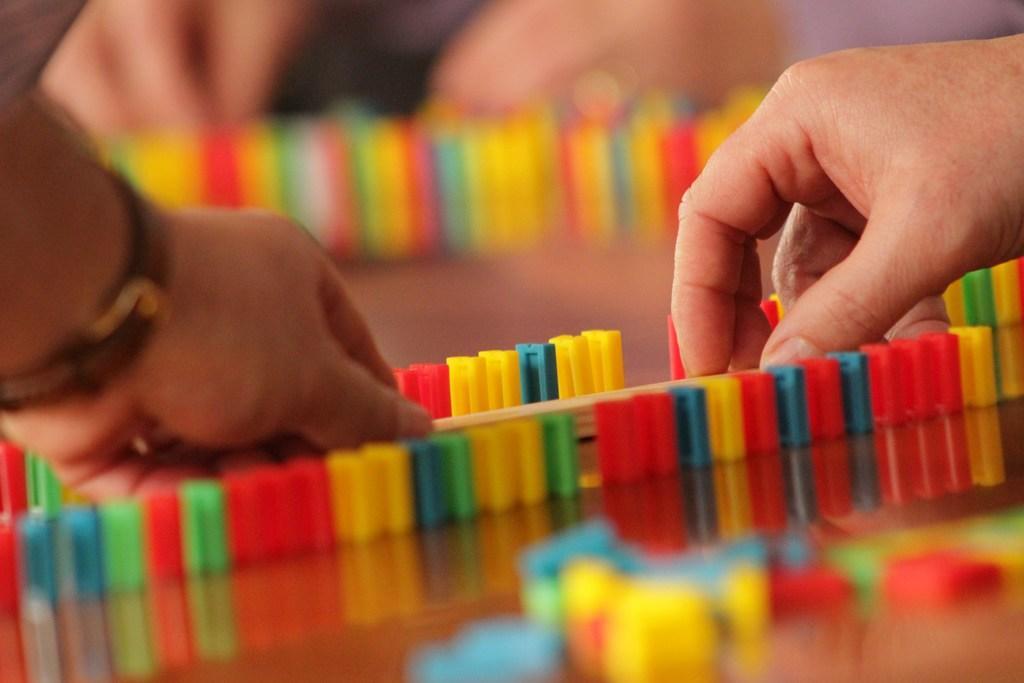Can you describe this image briefly? In this image I can see the person's hands and I can see few objects in multi color. 